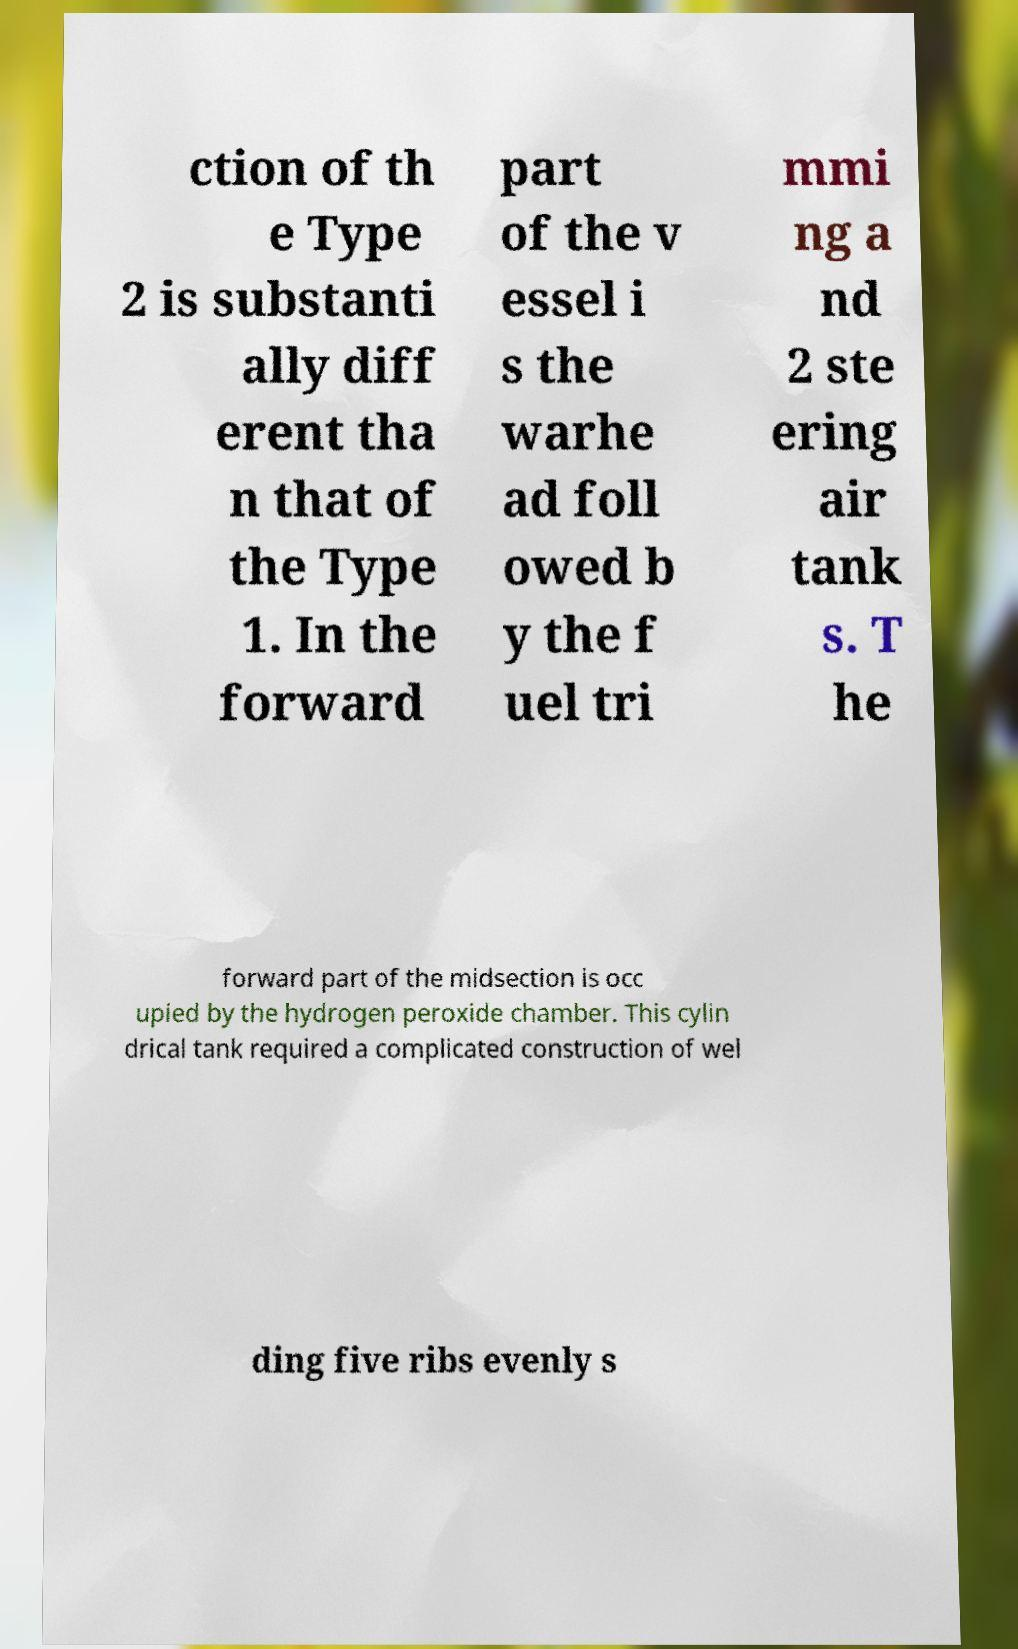What messages or text are displayed in this image? I need them in a readable, typed format. ction of th e Type 2 is substanti ally diff erent tha n that of the Type 1. In the forward part of the v essel i s the warhe ad foll owed b y the f uel tri mmi ng a nd 2 ste ering air tank s. T he forward part of the midsection is occ upied by the hydrogen peroxide chamber. This cylin drical tank required a complicated construction of wel ding five ribs evenly s 